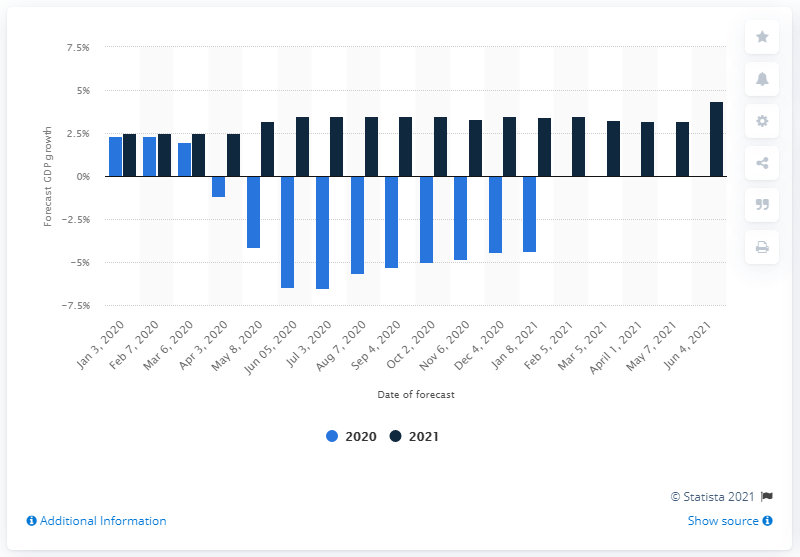Point out several critical features in this image. According to the forecast for the first week of June, Brazil's GDP was expected to grow by 4.36%. According to forecasts released in December 2020, Brazil's Gross Domestic Product (GDP) was expected to decrease by 4.36 percent. In April 2021, it was expected that Brazil's GDP would increase by 3.17%. During the first months of the year, Brazil's GDP growth was 2.3%. 